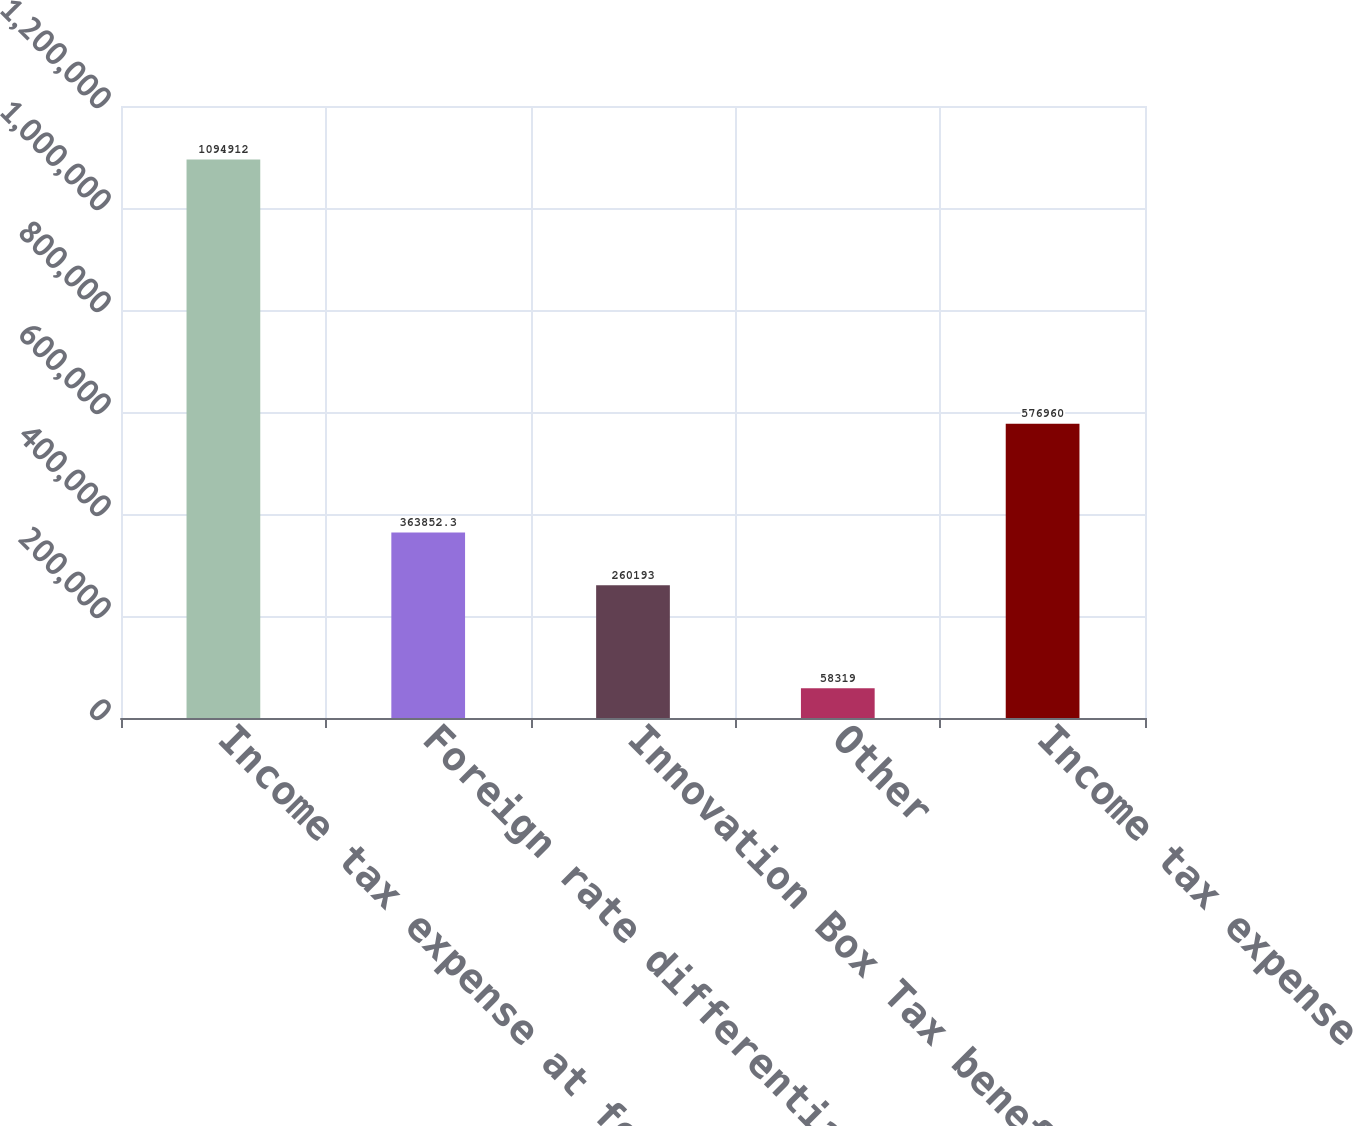Convert chart to OTSL. <chart><loc_0><loc_0><loc_500><loc_500><bar_chart><fcel>Income tax expense at federal<fcel>Foreign rate differential<fcel>Innovation Box Tax benefit<fcel>Other<fcel>Income tax expense<nl><fcel>1.09491e+06<fcel>363852<fcel>260193<fcel>58319<fcel>576960<nl></chart> 